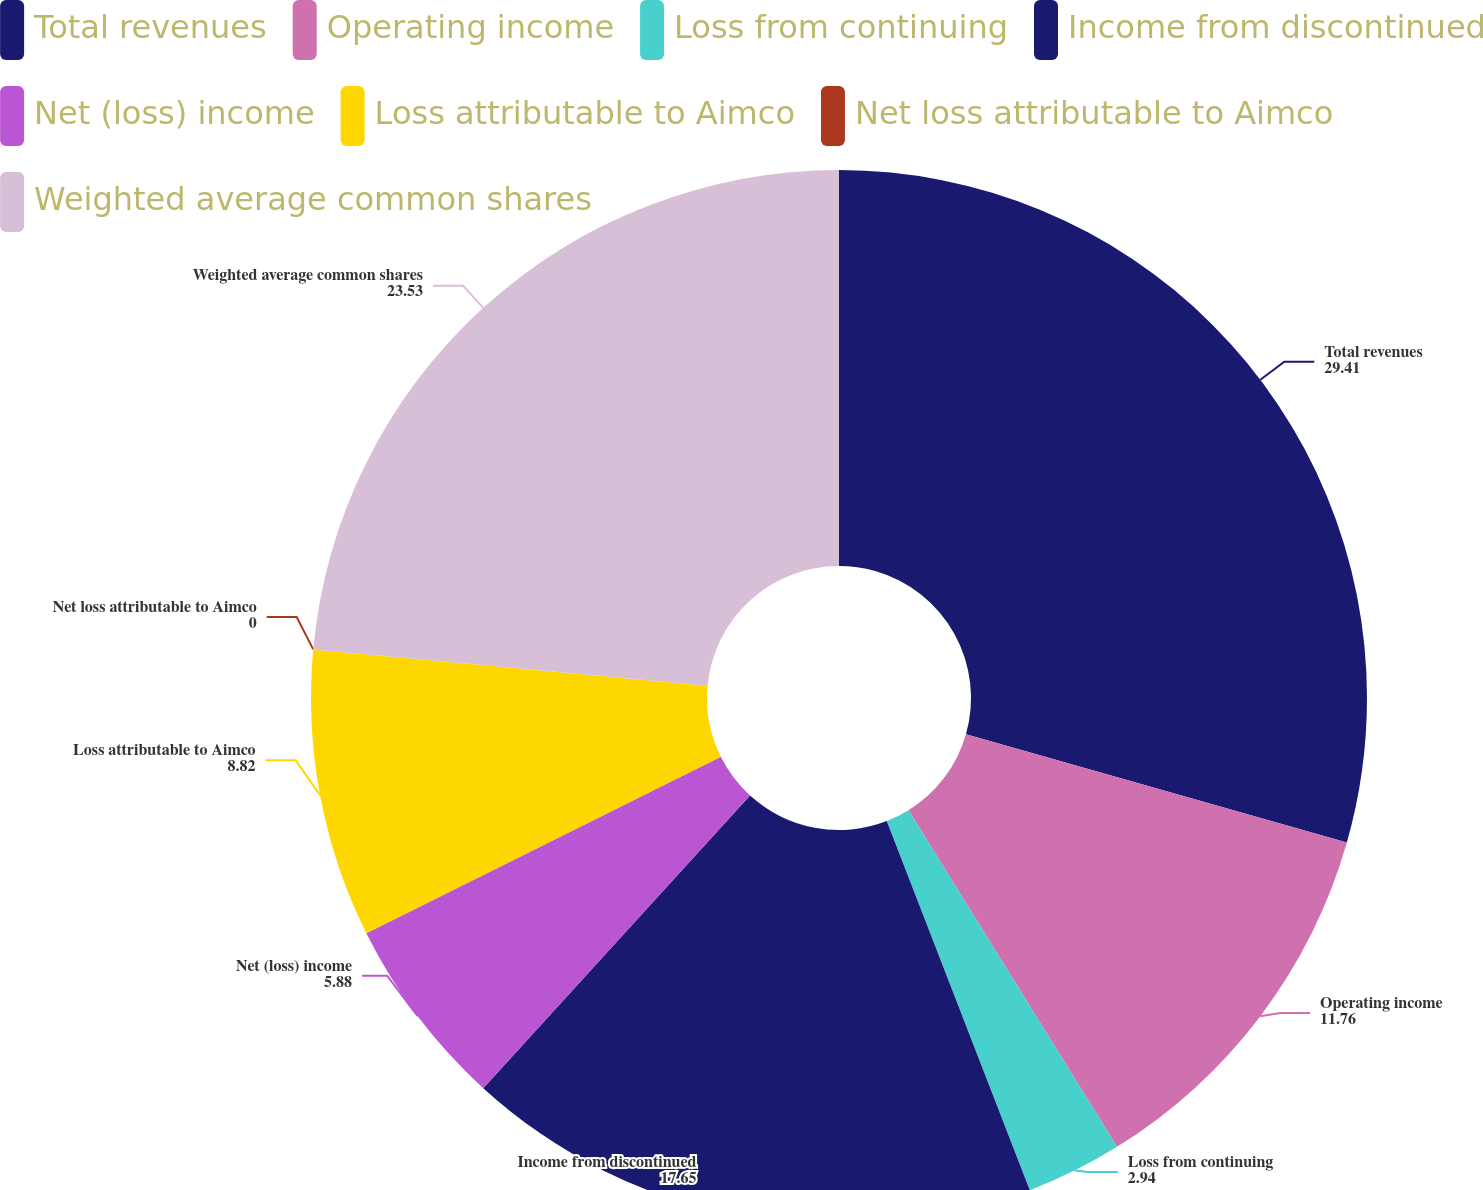<chart> <loc_0><loc_0><loc_500><loc_500><pie_chart><fcel>Total revenues<fcel>Operating income<fcel>Loss from continuing<fcel>Income from discontinued<fcel>Net (loss) income<fcel>Loss attributable to Aimco<fcel>Net loss attributable to Aimco<fcel>Weighted average common shares<nl><fcel>29.41%<fcel>11.76%<fcel>2.94%<fcel>17.65%<fcel>5.88%<fcel>8.82%<fcel>0.0%<fcel>23.53%<nl></chart> 